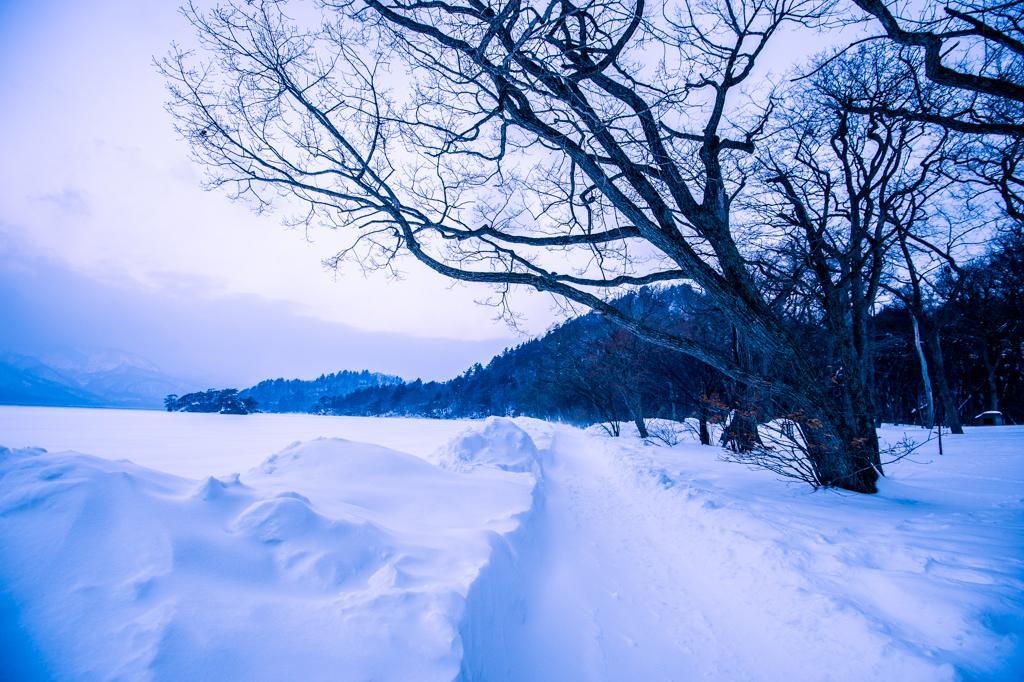Could you give a brief overview of what you see in this image? In this image in the foreground there is snow on the ground. In the background there are trees, hills. The sky is cloudy. 